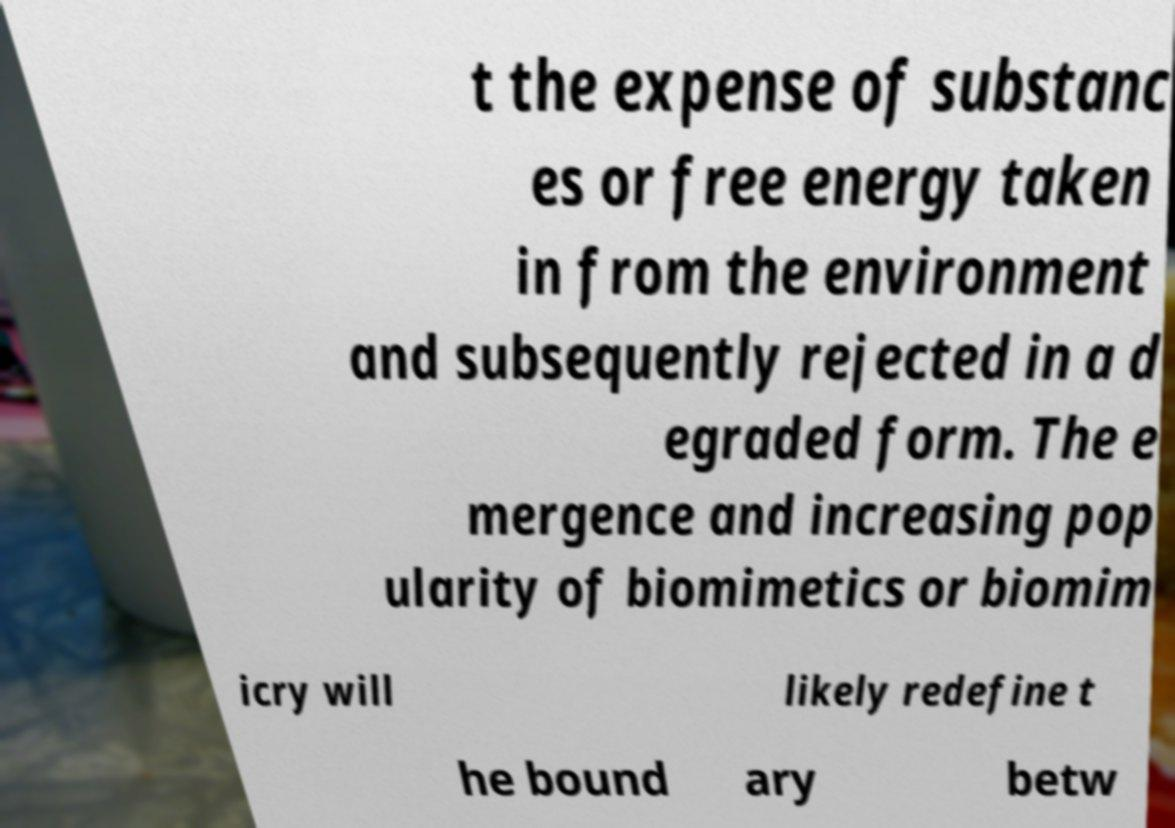Please identify and transcribe the text found in this image. t the expense of substanc es or free energy taken in from the environment and subsequently rejected in a d egraded form. The e mergence and increasing pop ularity of biomimetics or biomim icry will likely redefine t he bound ary betw 